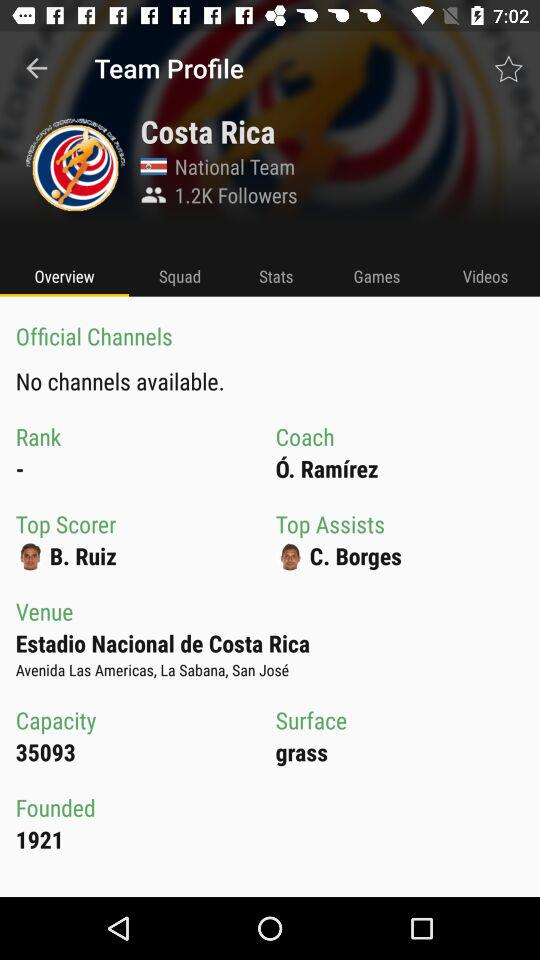Which tab is selected? The selected tab is "Overview". 